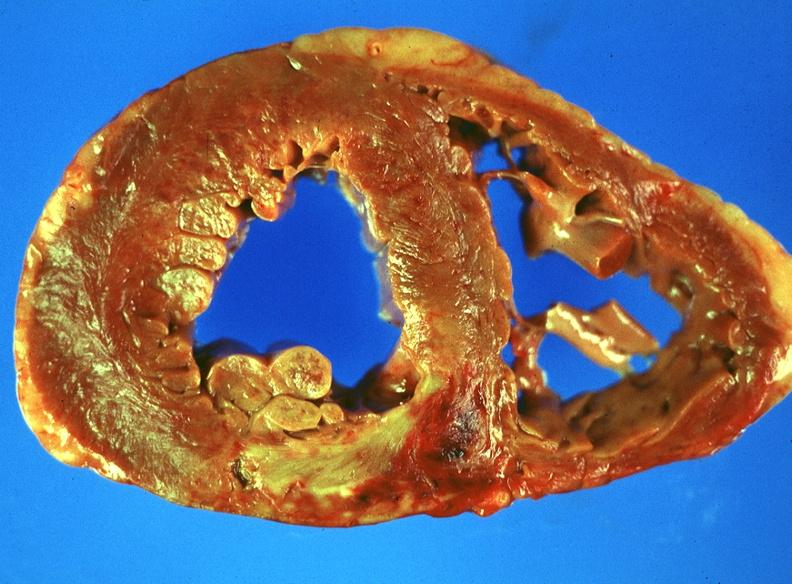s cardiovascular present?
Answer the question using a single word or phrase. Yes 